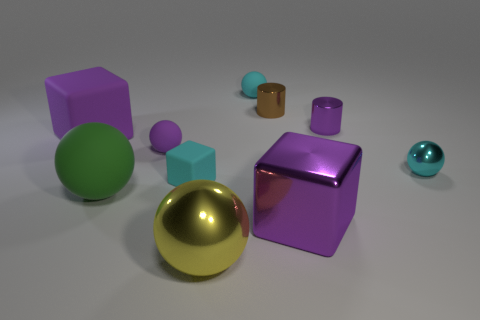There is a cyan object that is on the right side of the cyan ball behind the small purple thing behind the tiny purple matte sphere; what is its size?
Ensure brevity in your answer.  Small. What shape is the small metallic object that is the same color as the large shiny block?
Offer a very short reply. Cylinder. Does the cyan matte cube have the same size as the yellow shiny ball?
Ensure brevity in your answer.  No. Is the small cyan metal object the same shape as the big yellow metal object?
Your answer should be very brief. Yes. Is the number of purple objects left of the purple rubber sphere the same as the number of yellow objects?
Your answer should be very brief. Yes. How many other objects are there of the same material as the big green sphere?
Make the answer very short. 4. Is the size of the sphere in front of the purple metallic block the same as the purple cube right of the big green matte sphere?
Provide a succinct answer. Yes. What number of objects are either purple blocks that are on the left side of the yellow ball or tiny cyan things that are in front of the cyan rubber sphere?
Offer a terse response. 3. Is there any other thing that has the same shape as the green matte thing?
Your answer should be very brief. Yes. There is a block that is to the left of the green ball; does it have the same color as the cube that is in front of the green thing?
Offer a very short reply. Yes. 